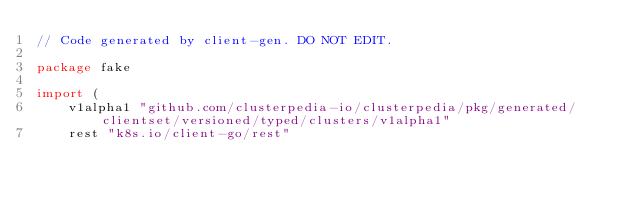<code> <loc_0><loc_0><loc_500><loc_500><_Go_>// Code generated by client-gen. DO NOT EDIT.

package fake

import (
	v1alpha1 "github.com/clusterpedia-io/clusterpedia/pkg/generated/clientset/versioned/typed/clusters/v1alpha1"
	rest "k8s.io/client-go/rest"</code> 